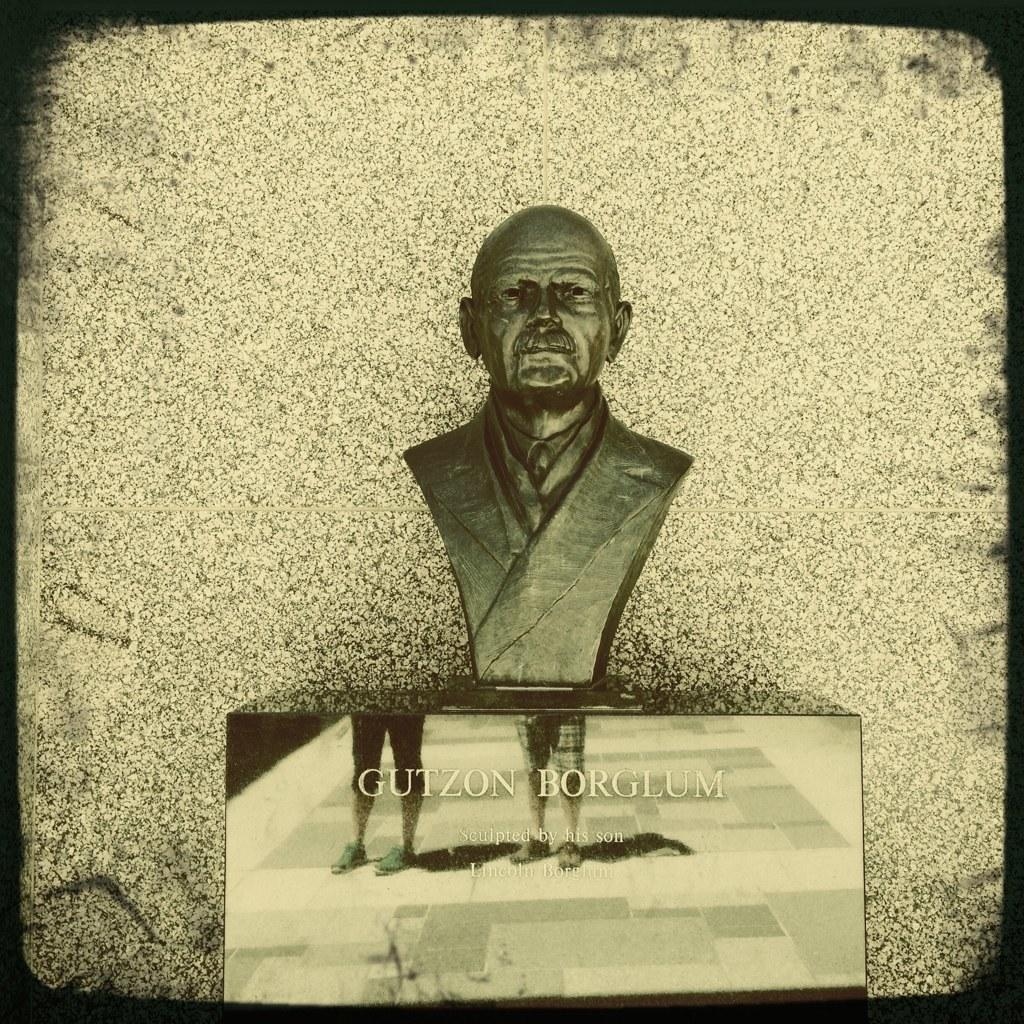What is located at the bottom of the image? There is a pedestal at the bottom of the image. What can be found on the pedestal? The pedestal has a name on it. What is depicted on top of the pedestal? There is a statue of a person on the pedestal. What is visible behind the statue? There is a wall behind the statue. What type of jam is being spread on the chair in the image? There is no jam or chair present in the image; it features a pedestal, a statue, and a wall. 